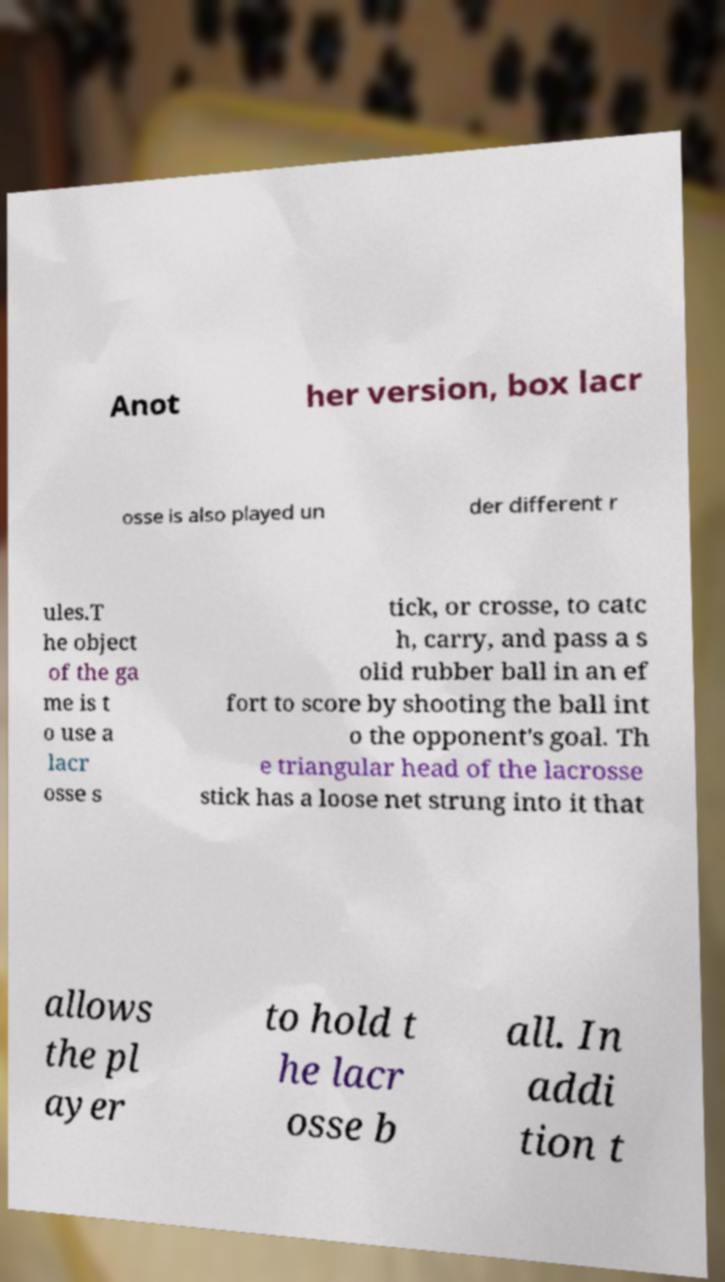For documentation purposes, I need the text within this image transcribed. Could you provide that? Anot her version, box lacr osse is also played un der different r ules.T he object of the ga me is t o use a lacr osse s tick, or crosse, to catc h, carry, and pass a s olid rubber ball in an ef fort to score by shooting the ball int o the opponent's goal. Th e triangular head of the lacrosse stick has a loose net strung into it that allows the pl ayer to hold t he lacr osse b all. In addi tion t 